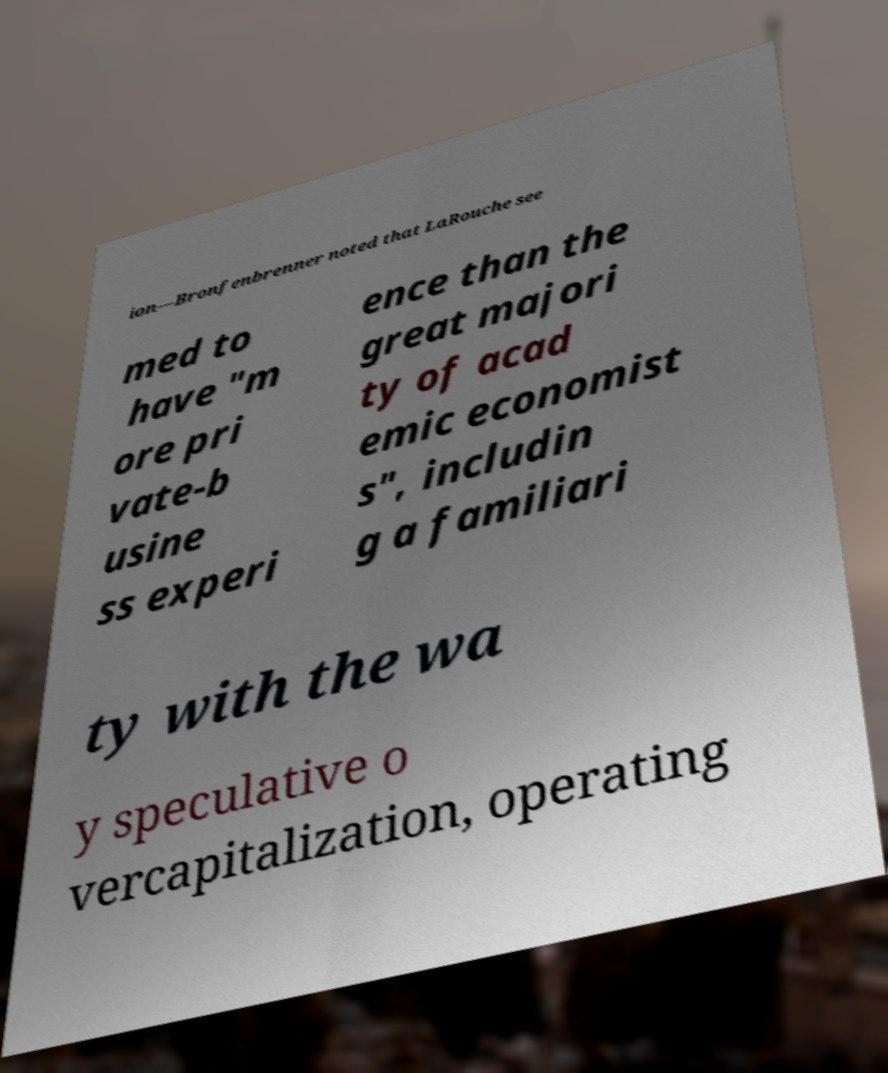Could you extract and type out the text from this image? ion—Bronfenbrenner noted that LaRouche see med to have "m ore pri vate-b usine ss experi ence than the great majori ty of acad emic economist s", includin g a familiari ty with the wa y speculative o vercapitalization, operating 